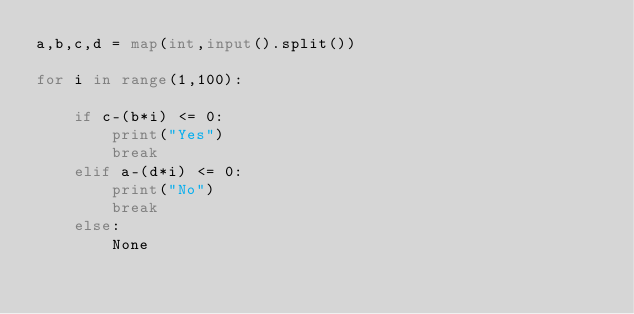Convert code to text. <code><loc_0><loc_0><loc_500><loc_500><_Python_>a,b,c,d = map(int,input().split())

for i in range(1,100):

    if c-(b*i) <= 0:
        print("Yes")
        break
    elif a-(d*i) <= 0:
        print("No")
        break
    else:
        None</code> 